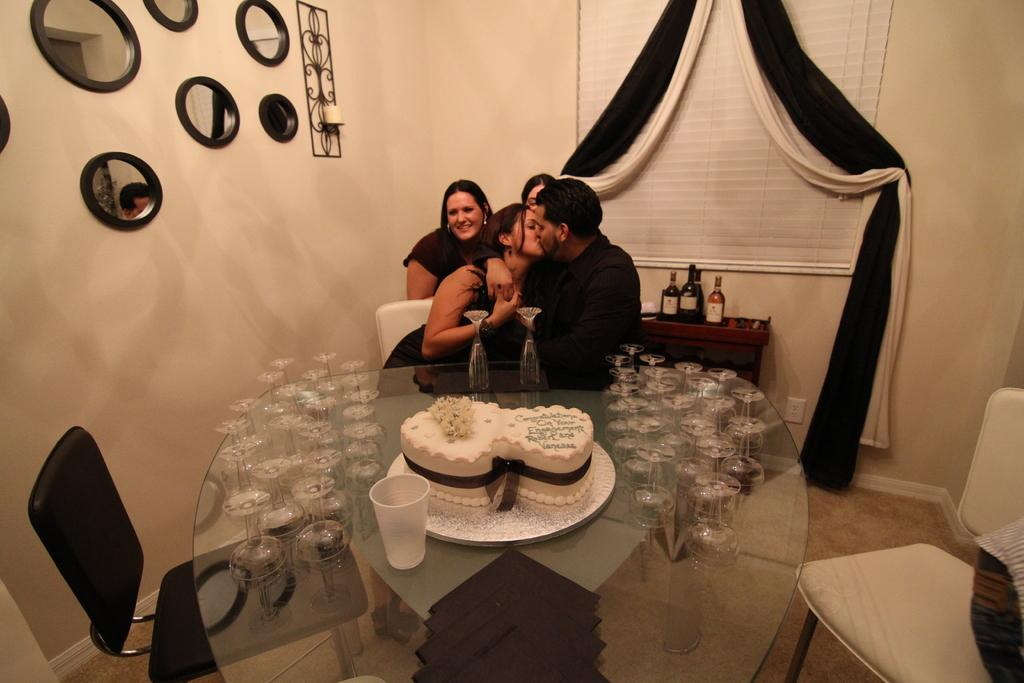What is the color of the wall in the image? The wall in the image is white. What objects are present in the image that can reflect images? There are mirrors in the image. What are the people in the image doing? The people are sitting on chairs in the image. What piece of furniture is present in the image? There is a table in the image. What items can be seen on the table? There are glasses and a cake on the table. Can you see any ants crawling on the cake in the image? There are no ants visible in the image, and therefore no such activity can be observed. What type of doll is sitting on the chair next to the cake? There is no doll present in the image; only people are sitting on the chairs. 